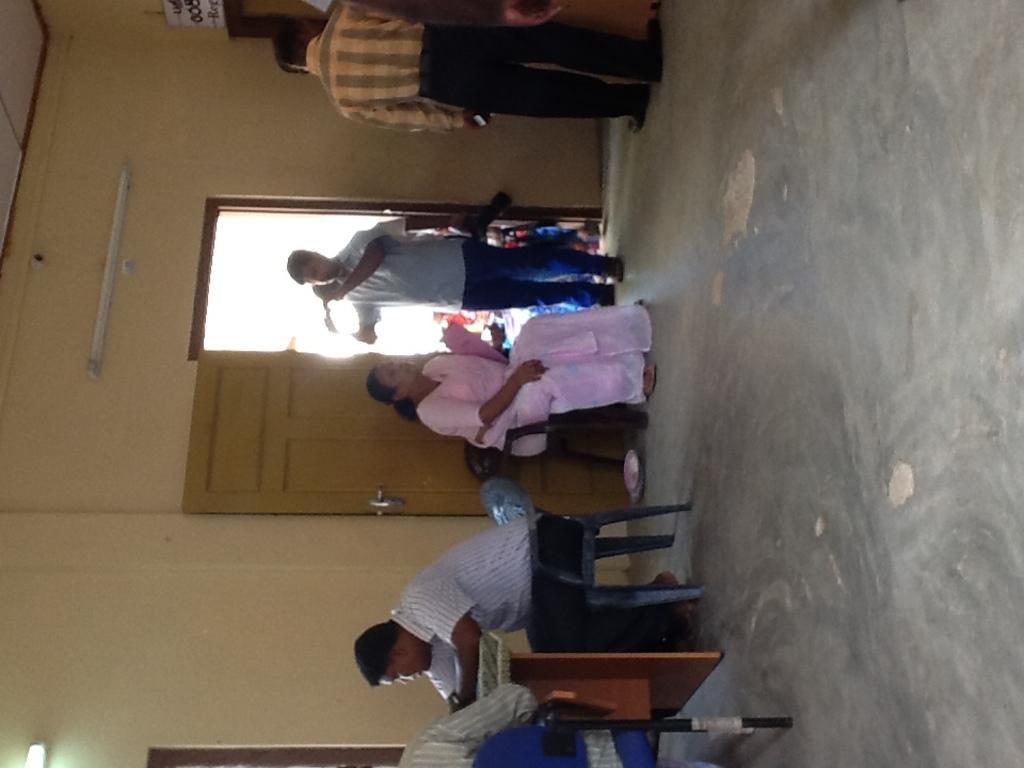Describe this image in one or two sentences. In this picture there are few people sitting in chairs and there is a person standing and holding a camera in his hand beside the door and there is another person standing beside him and there is a tube light attached to the wall above them. 